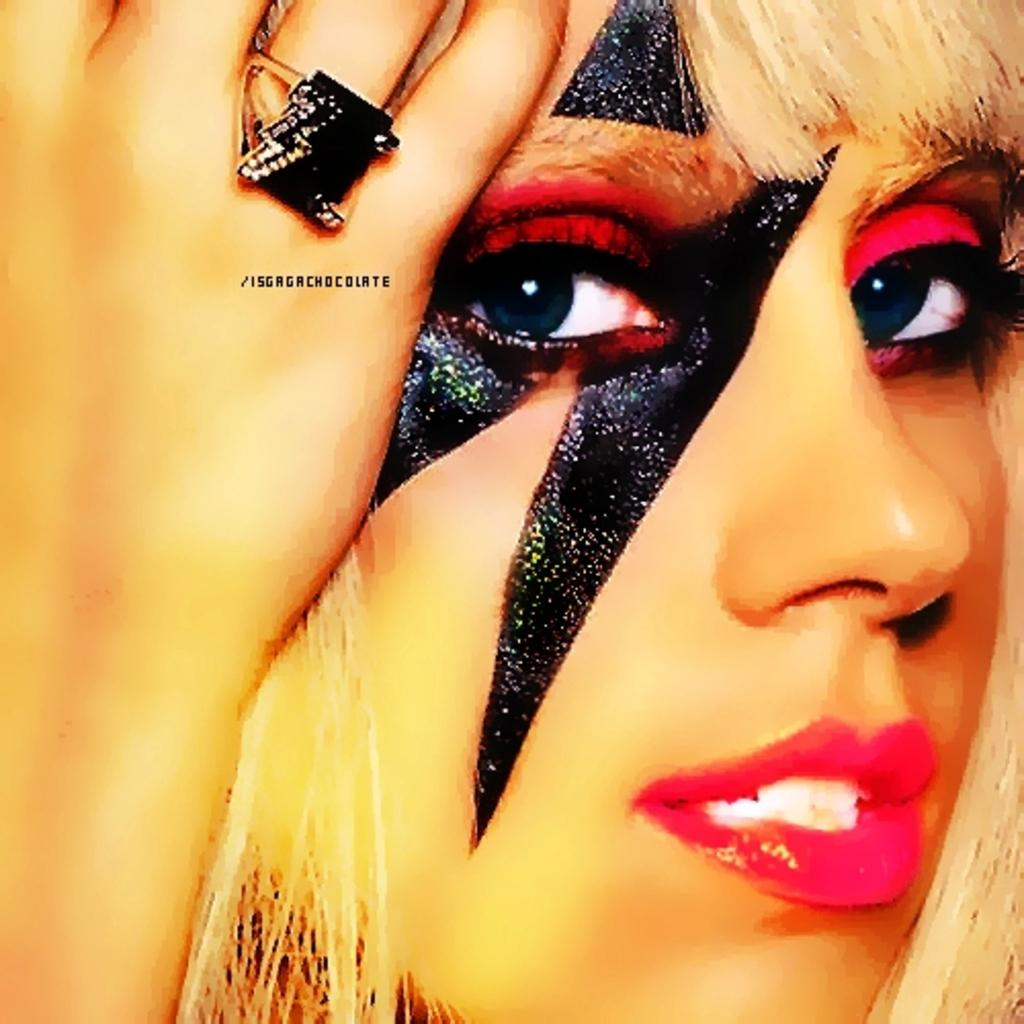Who is present in the image? There is a woman in the image. What is the woman wearing on her face? The woman is wearing a mask. What time is displayed on the clock in the image? There is no clock present in the image. 